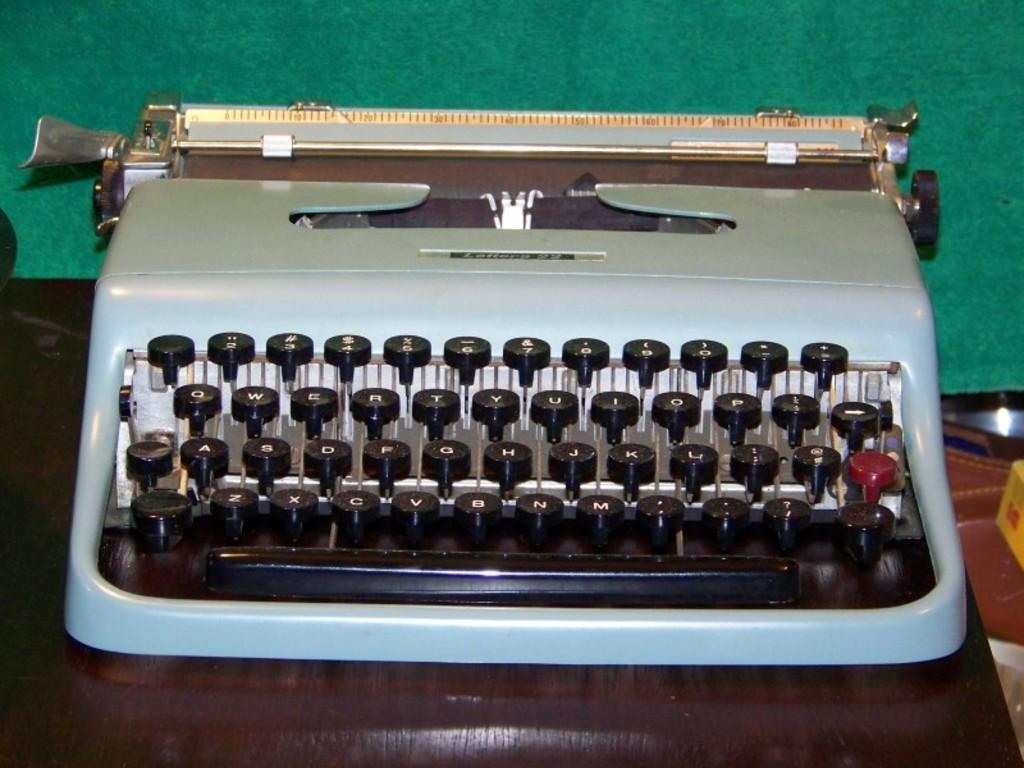What is the main object in the image? There is a typewriter in the image. What can be observed about the typewriter's keys? The typewriter has black color keys. On what surface is the typewriter placed? The typewriter is placed on a brown color table. What color is predominant in the background of the image? The background of the image is green. What type of game is being played in the image? There is no game being played in the image; it features a typewriter on a table. How quiet is the cave in the image? There is no cave present in the image; it features a typewriter on a table. 